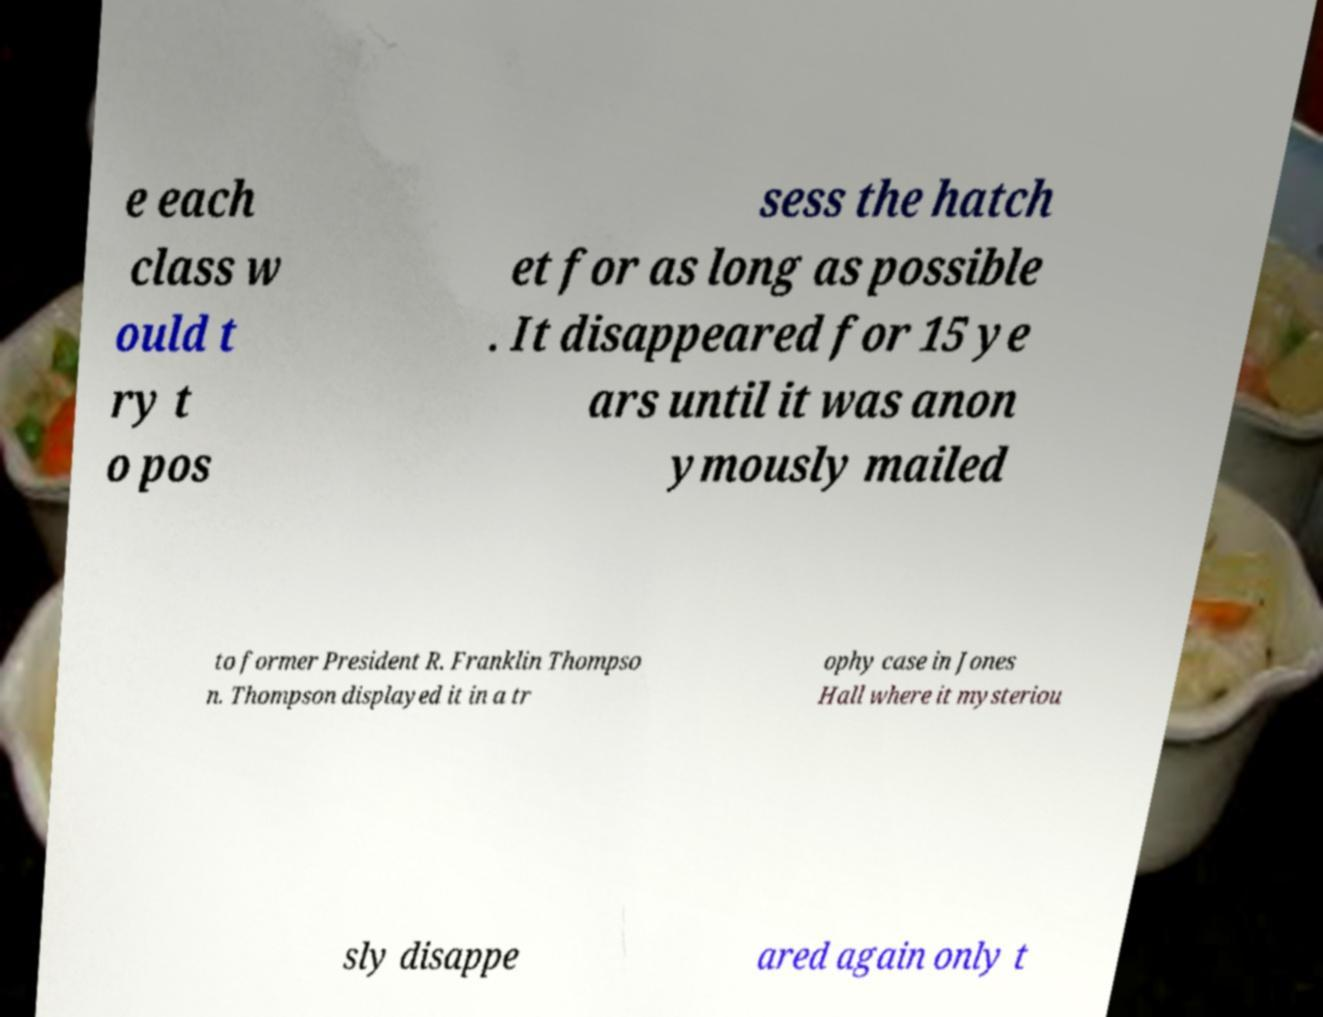Can you accurately transcribe the text from the provided image for me? e each class w ould t ry t o pos sess the hatch et for as long as possible . It disappeared for 15 ye ars until it was anon ymously mailed to former President R. Franklin Thompso n. Thompson displayed it in a tr ophy case in Jones Hall where it mysteriou sly disappe ared again only t 